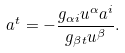Convert formula to latex. <formula><loc_0><loc_0><loc_500><loc_500>a ^ { t } = - \frac { g _ { \alpha i } u ^ { \alpha } a ^ { i } } { g _ { \beta t } u ^ { \beta } } .</formula> 